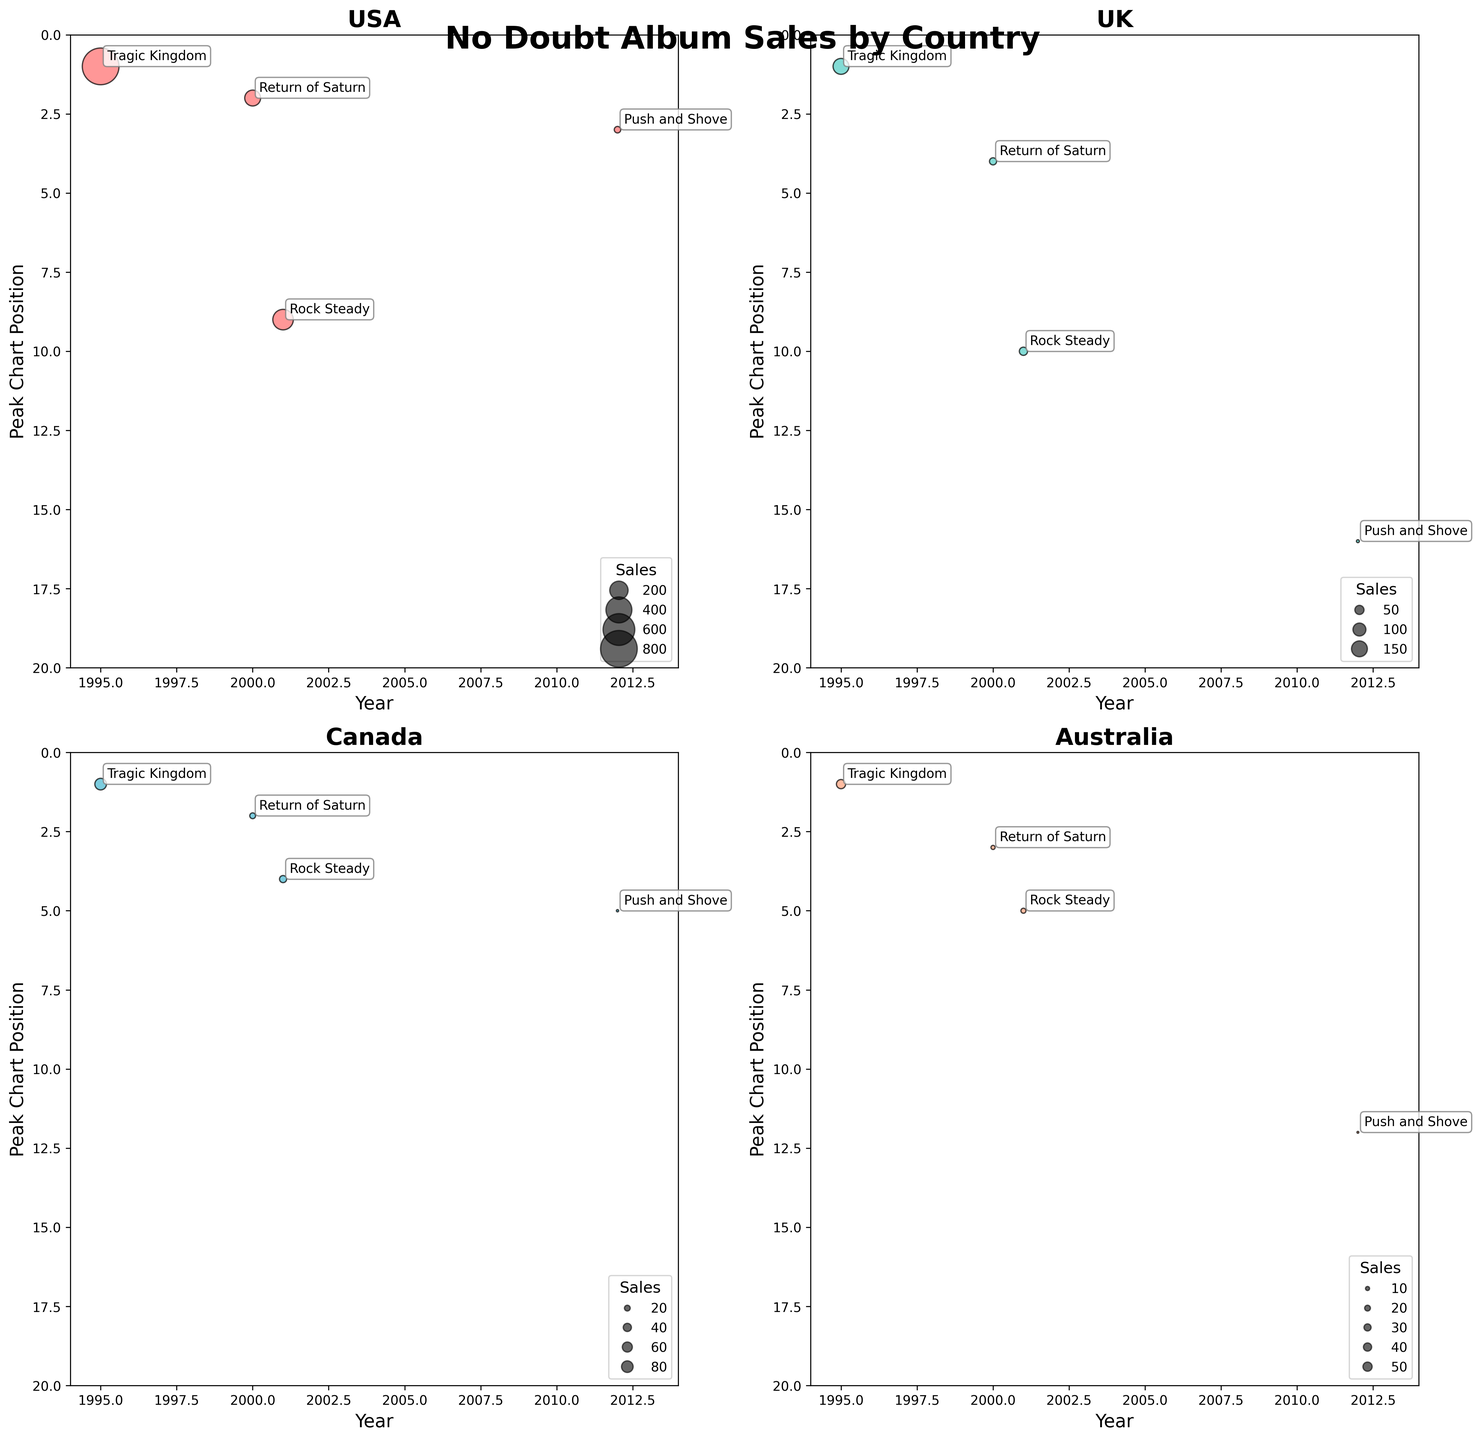What is the title of the figure? The title is positioned at the top of the chart. It can be read as "No Doubt Album Sales by Country."
Answer: No Doubt Album Sales by Country How many countries are included in these bubbles chart? Each subplot represents sales data from a specific country, and there are four subplots.
Answer: 4 Which album has the highest peak chart position in all of the plotted countries? Tragic Kingdom has a peak chart position of 1 in all four countries, as indicated by the y-axis value of 1 across the charts for the year 1995.
Answer: Tragic Kingdom What is the range of years displayed on the x-axis for each subplot? Checking the x-axis of each subplot shows the range begins at 1994 and ends at 2014.
Answer: 1994 to 2014 In the USA subplot, which album has the lowest peak chart position? In the USA subplot, tracing the y-axis, Rock Steady has a peak chart position of 9 in 2001, which is the lowest among all albums in the USA subplot.
Answer: Rock Steady Between 'Tragic Kingdom' and 'Return of Saturn,' which album had better average peak chart positions across all countries? Calculate the average peak position for each album across USA, UK, Canada, and Australia.
- Tragic Kingdom: (1 + 1 + 1 + 1) / 4 = 1
- Return of Saturn: (2 + 4 + 2 + 3) / 4 = 2.75
Tragic Kingdom has a better average peak chart position.
Answer: Tragic Kingdom Compare the sales of 'Rock Steady' in Canada and Australia. Which country had more sales and by how much? Check the sizes of the bubbles for both countries. For Canada, sales are 300,000. For Australia, sales are 150,000. Therefore, Canada had more sales by 300,000 - 150,000 = 150,000.
Answer: Canada by 150,000 How does the peak chart position for 'Push and Shove' in the UK compare to Canada? Check the UK subplot and Canada subplot for the year 2012. 'Push and Shove' has a peak chart position of 16 in the UK and 5 in Canada. Therefore, the UK had a worse peak chart position.
Answer: Worse in UK Which country saw an increase in album sales from 'Return of Saturn' to 'Rock Steady'? Compare the sizes of bubbles for these albums in all countries. In the USA, sales increased from 1,500,000 (Return of Saturn) to 2,500,000 (Rock Steady).
Answer: USA For 'Tragic Kingdom,' which country had the highest sales? How do you know? Compare the sizes of the bubbles for 'Tragic Kingdom' in each country. USA has the largest bubble with 8,000,000 sales.
Answer: USA 